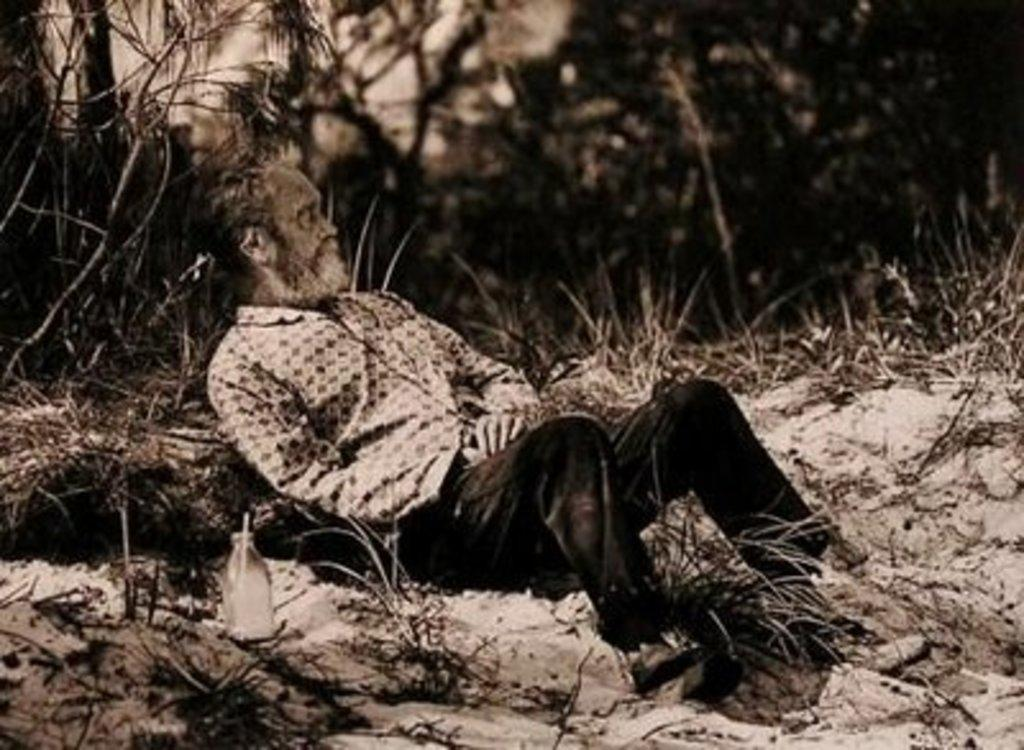What is the color scheme of the image? The image is black and white. What is the person in the image doing? The person is lying on the ground in the image. What object is beside the person? There is a bottle beside the person in the image. What type of vegetation can be seen in the image? Plants and a group of trees are visible in the image. What part of the natural environment is visible in the image? The sky is visible in the image. What type of destruction can be seen in the image? There is no destruction present in the image; it features a person lying on the ground with a bottle beside them, surrounded by plants, trees, and the sky. How many wings are visible in the image? There are no wings visible in the image. 